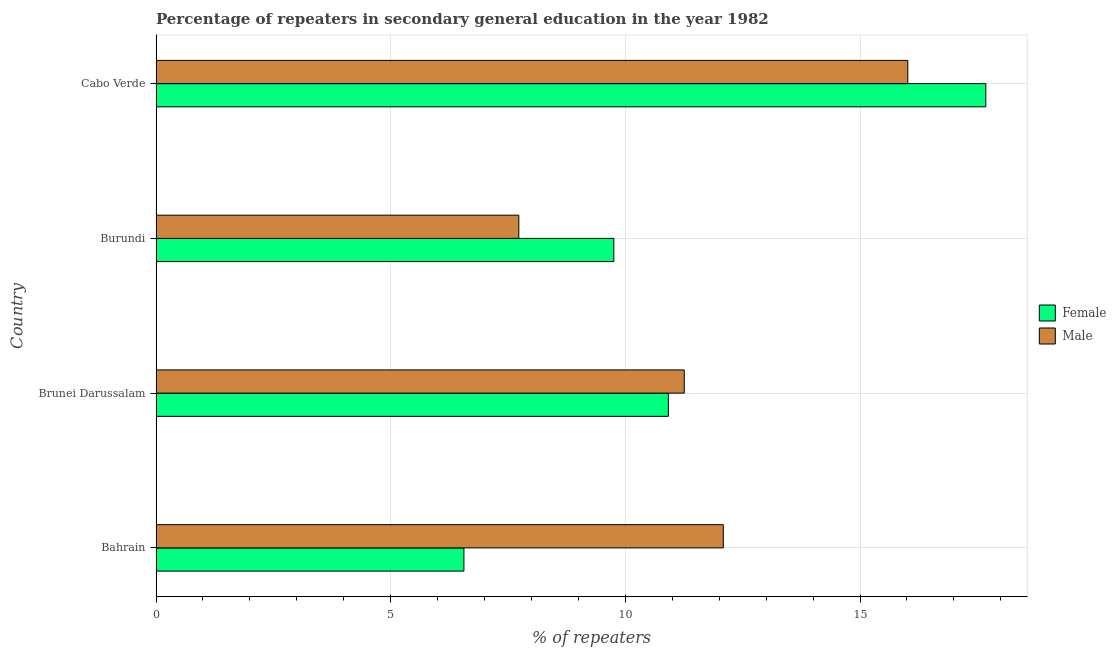How many bars are there on the 4th tick from the top?
Provide a short and direct response. 2. What is the label of the 1st group of bars from the top?
Your answer should be very brief. Cabo Verde. In how many cases, is the number of bars for a given country not equal to the number of legend labels?
Keep it short and to the point. 0. What is the percentage of female repeaters in Cabo Verde?
Make the answer very short. 17.68. Across all countries, what is the maximum percentage of male repeaters?
Offer a terse response. 16.02. Across all countries, what is the minimum percentage of male repeaters?
Your answer should be very brief. 7.73. In which country was the percentage of male repeaters maximum?
Your answer should be compact. Cabo Verde. In which country was the percentage of female repeaters minimum?
Make the answer very short. Bahrain. What is the total percentage of male repeaters in the graph?
Make the answer very short. 47.09. What is the difference between the percentage of female repeaters in Brunei Darussalam and that in Cabo Verde?
Your response must be concise. -6.76. What is the difference between the percentage of male repeaters in Bahrain and the percentage of female repeaters in Cabo Verde?
Make the answer very short. -5.59. What is the average percentage of male repeaters per country?
Your answer should be very brief. 11.77. What is the difference between the percentage of female repeaters and percentage of male repeaters in Burundi?
Your response must be concise. 2.02. What is the ratio of the percentage of female repeaters in Burundi to that in Cabo Verde?
Offer a terse response. 0.55. Is the percentage of male repeaters in Brunei Darussalam less than that in Burundi?
Give a very brief answer. No. Is the difference between the percentage of female repeaters in Burundi and Cabo Verde greater than the difference between the percentage of male repeaters in Burundi and Cabo Verde?
Ensure brevity in your answer.  Yes. What is the difference between the highest and the second highest percentage of female repeaters?
Offer a very short reply. 6.76. What is the difference between the highest and the lowest percentage of male repeaters?
Make the answer very short. 8.29. In how many countries, is the percentage of male repeaters greater than the average percentage of male repeaters taken over all countries?
Provide a short and direct response. 2. What does the 1st bar from the bottom in Burundi represents?
Keep it short and to the point. Female. How many bars are there?
Offer a very short reply. 8. How many countries are there in the graph?
Your answer should be very brief. 4. What is the difference between two consecutive major ticks on the X-axis?
Make the answer very short. 5. Are the values on the major ticks of X-axis written in scientific E-notation?
Provide a short and direct response. No. Does the graph contain grids?
Offer a very short reply. Yes. What is the title of the graph?
Offer a terse response. Percentage of repeaters in secondary general education in the year 1982. Does "Diesel" appear as one of the legend labels in the graph?
Offer a very short reply. No. What is the label or title of the X-axis?
Your answer should be very brief. % of repeaters. What is the % of repeaters of Female in Bahrain?
Give a very brief answer. 6.56. What is the % of repeaters of Male in Bahrain?
Keep it short and to the point. 12.09. What is the % of repeaters of Female in Brunei Darussalam?
Give a very brief answer. 10.92. What is the % of repeaters in Male in Brunei Darussalam?
Your answer should be very brief. 11.25. What is the % of repeaters in Female in Burundi?
Give a very brief answer. 9.75. What is the % of repeaters of Male in Burundi?
Make the answer very short. 7.73. What is the % of repeaters in Female in Cabo Verde?
Your answer should be compact. 17.68. What is the % of repeaters of Male in Cabo Verde?
Ensure brevity in your answer.  16.02. Across all countries, what is the maximum % of repeaters of Female?
Provide a succinct answer. 17.68. Across all countries, what is the maximum % of repeaters of Male?
Your answer should be compact. 16.02. Across all countries, what is the minimum % of repeaters of Female?
Offer a terse response. 6.56. Across all countries, what is the minimum % of repeaters of Male?
Your answer should be very brief. 7.73. What is the total % of repeaters in Female in the graph?
Provide a short and direct response. 44.91. What is the total % of repeaters in Male in the graph?
Provide a succinct answer. 47.09. What is the difference between the % of repeaters of Female in Bahrain and that in Brunei Darussalam?
Provide a succinct answer. -4.36. What is the difference between the % of repeaters of Male in Bahrain and that in Brunei Darussalam?
Your answer should be very brief. 0.83. What is the difference between the % of repeaters of Female in Bahrain and that in Burundi?
Ensure brevity in your answer.  -3.19. What is the difference between the % of repeaters of Male in Bahrain and that in Burundi?
Your response must be concise. 4.36. What is the difference between the % of repeaters in Female in Bahrain and that in Cabo Verde?
Offer a very short reply. -11.12. What is the difference between the % of repeaters in Male in Bahrain and that in Cabo Verde?
Provide a short and direct response. -3.93. What is the difference between the % of repeaters of Female in Brunei Darussalam and that in Burundi?
Offer a very short reply. 1.16. What is the difference between the % of repeaters of Male in Brunei Darussalam and that in Burundi?
Give a very brief answer. 3.52. What is the difference between the % of repeaters of Female in Brunei Darussalam and that in Cabo Verde?
Offer a very short reply. -6.76. What is the difference between the % of repeaters of Male in Brunei Darussalam and that in Cabo Verde?
Ensure brevity in your answer.  -4.76. What is the difference between the % of repeaters in Female in Burundi and that in Cabo Verde?
Make the answer very short. -7.93. What is the difference between the % of repeaters in Male in Burundi and that in Cabo Verde?
Offer a very short reply. -8.29. What is the difference between the % of repeaters in Female in Bahrain and the % of repeaters in Male in Brunei Darussalam?
Offer a very short reply. -4.69. What is the difference between the % of repeaters in Female in Bahrain and the % of repeaters in Male in Burundi?
Provide a succinct answer. -1.17. What is the difference between the % of repeaters in Female in Bahrain and the % of repeaters in Male in Cabo Verde?
Provide a succinct answer. -9.46. What is the difference between the % of repeaters in Female in Brunei Darussalam and the % of repeaters in Male in Burundi?
Your response must be concise. 3.19. What is the difference between the % of repeaters in Female in Brunei Darussalam and the % of repeaters in Male in Cabo Verde?
Keep it short and to the point. -5.1. What is the difference between the % of repeaters in Female in Burundi and the % of repeaters in Male in Cabo Verde?
Offer a very short reply. -6.26. What is the average % of repeaters of Female per country?
Your answer should be very brief. 11.23. What is the average % of repeaters of Male per country?
Give a very brief answer. 11.77. What is the difference between the % of repeaters in Female and % of repeaters in Male in Bahrain?
Keep it short and to the point. -5.53. What is the difference between the % of repeaters of Female and % of repeaters of Male in Brunei Darussalam?
Provide a short and direct response. -0.34. What is the difference between the % of repeaters in Female and % of repeaters in Male in Burundi?
Offer a very short reply. 2.02. What is the difference between the % of repeaters of Female and % of repeaters of Male in Cabo Verde?
Offer a terse response. 1.66. What is the ratio of the % of repeaters of Female in Bahrain to that in Brunei Darussalam?
Offer a very short reply. 0.6. What is the ratio of the % of repeaters of Male in Bahrain to that in Brunei Darussalam?
Keep it short and to the point. 1.07. What is the ratio of the % of repeaters of Female in Bahrain to that in Burundi?
Make the answer very short. 0.67. What is the ratio of the % of repeaters of Male in Bahrain to that in Burundi?
Your answer should be very brief. 1.56. What is the ratio of the % of repeaters of Female in Bahrain to that in Cabo Verde?
Offer a very short reply. 0.37. What is the ratio of the % of repeaters of Male in Bahrain to that in Cabo Verde?
Your answer should be compact. 0.75. What is the ratio of the % of repeaters in Female in Brunei Darussalam to that in Burundi?
Your answer should be compact. 1.12. What is the ratio of the % of repeaters in Male in Brunei Darussalam to that in Burundi?
Offer a terse response. 1.46. What is the ratio of the % of repeaters in Female in Brunei Darussalam to that in Cabo Verde?
Give a very brief answer. 0.62. What is the ratio of the % of repeaters in Male in Brunei Darussalam to that in Cabo Verde?
Keep it short and to the point. 0.7. What is the ratio of the % of repeaters of Female in Burundi to that in Cabo Verde?
Keep it short and to the point. 0.55. What is the ratio of the % of repeaters in Male in Burundi to that in Cabo Verde?
Offer a terse response. 0.48. What is the difference between the highest and the second highest % of repeaters in Female?
Your response must be concise. 6.76. What is the difference between the highest and the second highest % of repeaters in Male?
Provide a short and direct response. 3.93. What is the difference between the highest and the lowest % of repeaters in Female?
Give a very brief answer. 11.12. What is the difference between the highest and the lowest % of repeaters in Male?
Ensure brevity in your answer.  8.29. 